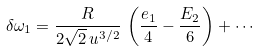<formula> <loc_0><loc_0><loc_500><loc_500>\delta \omega _ { 1 } = \frac { R } { 2 \sqrt { 2 } \, u ^ { 3 / 2 } } \, \left ( \frac { e _ { 1 } } { 4 } - \frac { E _ { 2 } } { 6 } \right ) + \cdots</formula> 